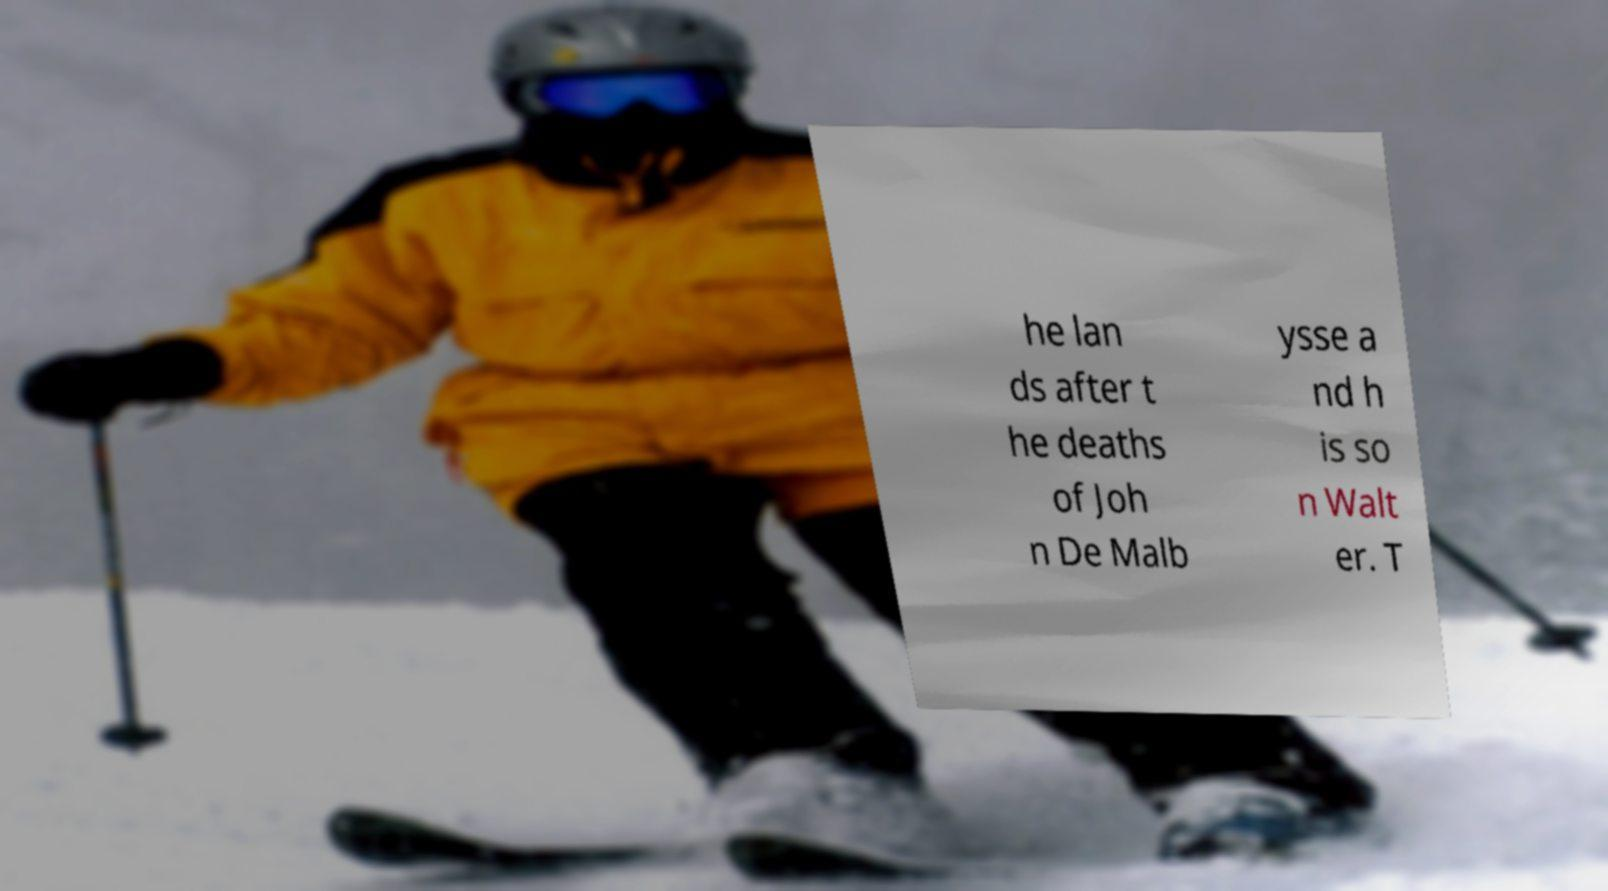Please identify and transcribe the text found in this image. he lan ds after t he deaths of Joh n De Malb ysse a nd h is so n Walt er. T 